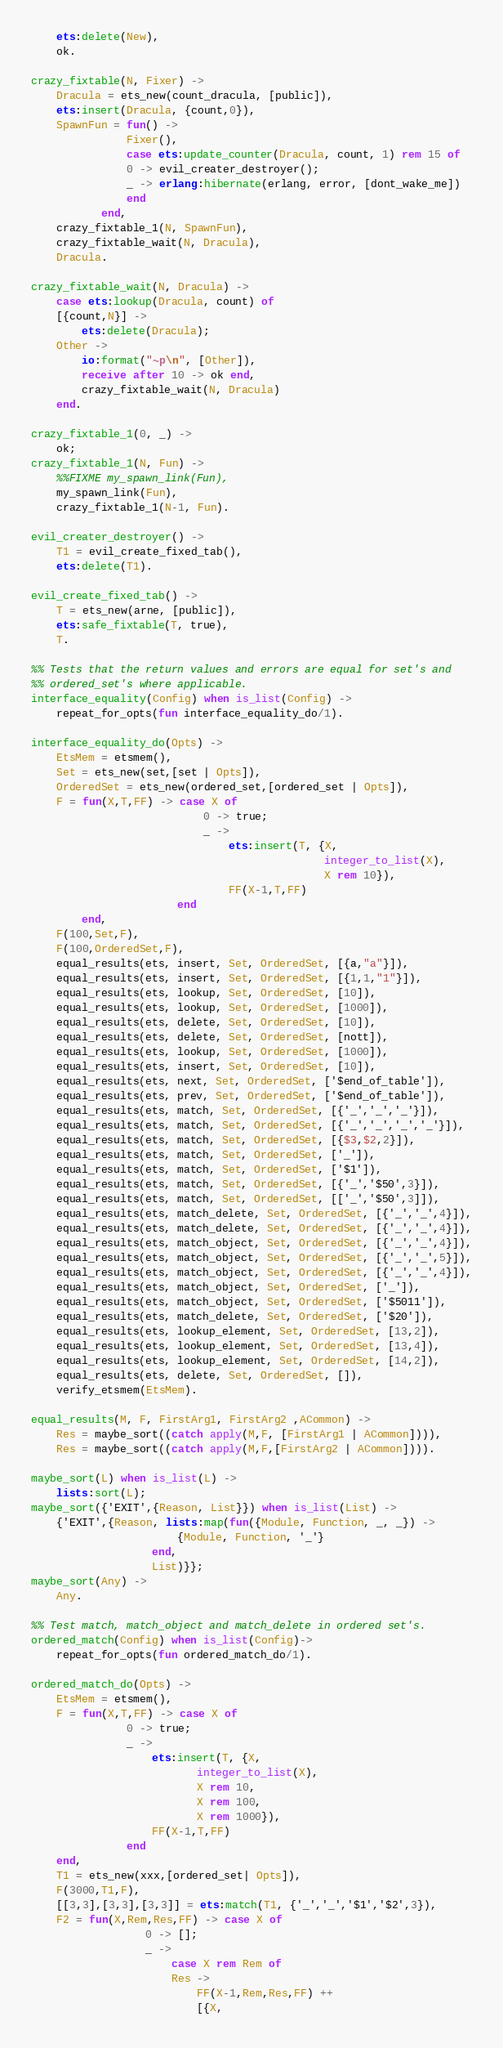Convert code to text. <code><loc_0><loc_0><loc_500><loc_500><_Erlang_>    ets:delete(New),
    ok.

crazy_fixtable(N, Fixer) ->
    Dracula = ets_new(count_dracula, [public]),
    ets:insert(Dracula, {count,0}),
    SpawnFun = fun() ->
		       Fixer(),
		       case ets:update_counter(Dracula, count, 1) rem 15 of
			   0 -> evil_creater_destroyer();
			   _ -> erlang:hibernate(erlang, error, [dont_wake_me])
		       end
	       end,
    crazy_fixtable_1(N, SpawnFun),
    crazy_fixtable_wait(N, Dracula),
    Dracula.

crazy_fixtable_wait(N, Dracula) ->
    case ets:lookup(Dracula, count) of
	[{count,N}] ->
	    ets:delete(Dracula);
	Other ->
	    io:format("~p\n", [Other]),
	    receive after 10 -> ok end,
	    crazy_fixtable_wait(N, Dracula)
    end.

crazy_fixtable_1(0, _) ->
    ok;
crazy_fixtable_1(N, Fun) ->
    %%FIXME my_spawn_link(Fun),
    my_spawn_link(Fun),
    crazy_fixtable_1(N-1, Fun).

evil_creater_destroyer() ->
    T1 = evil_create_fixed_tab(),
    ets:delete(T1).

evil_create_fixed_tab() ->
    T = ets_new(arne, [public]),
    ets:safe_fixtable(T, true),
    T.

%% Tests that the return values and errors are equal for set's and
%% ordered_set's where applicable.
interface_equality(Config) when is_list(Config) ->
    repeat_for_opts(fun interface_equality_do/1).

interface_equality_do(Opts) ->
    EtsMem = etsmem(),
    Set = ets_new(set,[set | Opts]),
    OrderedSet = ets_new(ordered_set,[ordered_set | Opts]),
    F = fun(X,T,FF) -> case X of
                           0 -> true;
                           _ ->
                               ets:insert(T, {X,
                                              integer_to_list(X),
                                              X rem 10}),
                               FF(X-1,T,FF)
                       end
        end,
    F(100,Set,F),
    F(100,OrderedSet,F),
    equal_results(ets, insert, Set, OrderedSet, [{a,"a"}]),
    equal_results(ets, insert, Set, OrderedSet, [{1,1,"1"}]),
    equal_results(ets, lookup, Set, OrderedSet, [10]),
    equal_results(ets, lookup, Set, OrderedSet, [1000]),
    equal_results(ets, delete, Set, OrderedSet, [10]),
    equal_results(ets, delete, Set, OrderedSet, [nott]),
    equal_results(ets, lookup, Set, OrderedSet, [1000]),
    equal_results(ets, insert, Set, OrderedSet, [10]),
    equal_results(ets, next, Set, OrderedSet, ['$end_of_table']),
    equal_results(ets, prev, Set, OrderedSet, ['$end_of_table']),
    equal_results(ets, match, Set, OrderedSet, [{'_','_','_'}]),
    equal_results(ets, match, Set, OrderedSet, [{'_','_','_','_'}]),
    equal_results(ets, match, Set, OrderedSet, [{$3,$2,2}]),
    equal_results(ets, match, Set, OrderedSet, ['_']),
    equal_results(ets, match, Set, OrderedSet, ['$1']),
    equal_results(ets, match, Set, OrderedSet, [{'_','$50',3}]),
    equal_results(ets, match, Set, OrderedSet, [['_','$50',3]]),
    equal_results(ets, match_delete, Set, OrderedSet, [{'_','_',4}]),
    equal_results(ets, match_delete, Set, OrderedSet, [{'_','_',4}]),
    equal_results(ets, match_object, Set, OrderedSet, [{'_','_',4}]),
    equal_results(ets, match_object, Set, OrderedSet, [{'_','_',5}]),
    equal_results(ets, match_object, Set, OrderedSet, [{'_','_',4}]),
    equal_results(ets, match_object, Set, OrderedSet, ['_']),
    equal_results(ets, match_object, Set, OrderedSet, ['$5011']),
    equal_results(ets, match_delete, Set, OrderedSet, ['$20']),
    equal_results(ets, lookup_element, Set, OrderedSet, [13,2]),
    equal_results(ets, lookup_element, Set, OrderedSet, [13,4]),
    equal_results(ets, lookup_element, Set, OrderedSet, [14,2]),
    equal_results(ets, delete, Set, OrderedSet, []),
    verify_etsmem(EtsMem).

equal_results(M, F, FirstArg1, FirstArg2 ,ACommon) ->
    Res = maybe_sort((catch apply(M,F, [FirstArg1 | ACommon]))),
    Res = maybe_sort((catch apply(M,F,[FirstArg2 | ACommon]))).

maybe_sort(L) when is_list(L) ->
    lists:sort(L);
maybe_sort({'EXIT',{Reason, List}}) when is_list(List) ->
    {'EXIT',{Reason, lists:map(fun({Module, Function, _, _}) ->
				       {Module, Function, '_'}
			       end,
			       List)}};
maybe_sort(Any) ->
    Any.

%% Test match, match_object and match_delete in ordered set's.
ordered_match(Config) when is_list(Config)->
    repeat_for_opts(fun ordered_match_do/1).

ordered_match_do(Opts) ->
    EtsMem = etsmem(),
    F = fun(X,T,FF) -> case X of
			   0 -> true;
			   _ ->
			       ets:insert(T, {X,
					      integer_to_list(X),
					      X rem 10,
					      X rem 100,
					      X rem 1000}),
			       FF(X-1,T,FF)
		       end
	end,
    T1 = ets_new(xxx,[ordered_set| Opts]),
    F(3000,T1,F),
    [[3,3],[3,3],[3,3]] = ets:match(T1, {'_','_','$1','$2',3}),
    F2 = fun(X,Rem,Res,FF) -> case X of
				  0 -> [];
				  _ ->
				      case X rem Rem of
					  Res ->
					      FF(X-1,Rem,Res,FF) ++
						  [{X,</code> 